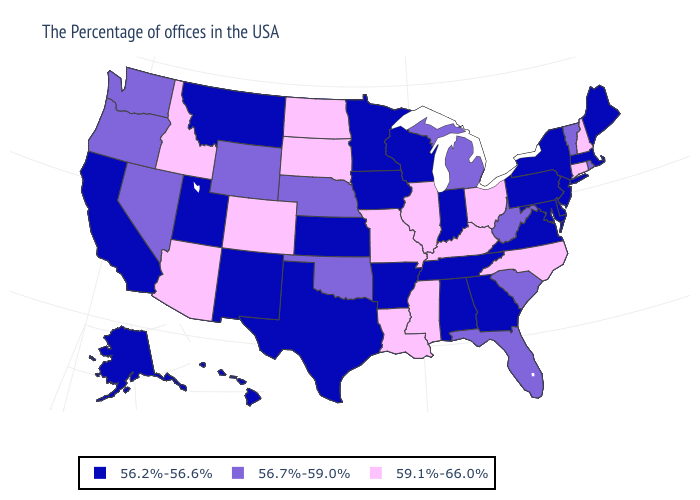Among the states that border Pennsylvania , does New Jersey have the highest value?
Short answer required. No. Does the map have missing data?
Write a very short answer. No. What is the highest value in states that border Colorado?
Concise answer only. 59.1%-66.0%. Does the first symbol in the legend represent the smallest category?
Quick response, please. Yes. What is the lowest value in the USA?
Concise answer only. 56.2%-56.6%. Does Arkansas have a lower value than California?
Answer briefly. No. What is the value of Minnesota?
Write a very short answer. 56.2%-56.6%. Name the states that have a value in the range 56.2%-56.6%?
Quick response, please. Maine, Massachusetts, New York, New Jersey, Delaware, Maryland, Pennsylvania, Virginia, Georgia, Indiana, Alabama, Tennessee, Wisconsin, Arkansas, Minnesota, Iowa, Kansas, Texas, New Mexico, Utah, Montana, California, Alaska, Hawaii. What is the lowest value in states that border Kentucky?
Write a very short answer. 56.2%-56.6%. Does the first symbol in the legend represent the smallest category?
Answer briefly. Yes. Name the states that have a value in the range 56.7%-59.0%?
Be succinct. Rhode Island, Vermont, South Carolina, West Virginia, Florida, Michigan, Nebraska, Oklahoma, Wyoming, Nevada, Washington, Oregon. What is the highest value in the USA?
Answer briefly. 59.1%-66.0%. Which states have the highest value in the USA?
Keep it brief. New Hampshire, Connecticut, North Carolina, Ohio, Kentucky, Illinois, Mississippi, Louisiana, Missouri, South Dakota, North Dakota, Colorado, Arizona, Idaho. What is the highest value in the South ?
Keep it brief. 59.1%-66.0%. Does Delaware have the lowest value in the USA?
Answer briefly. Yes. 